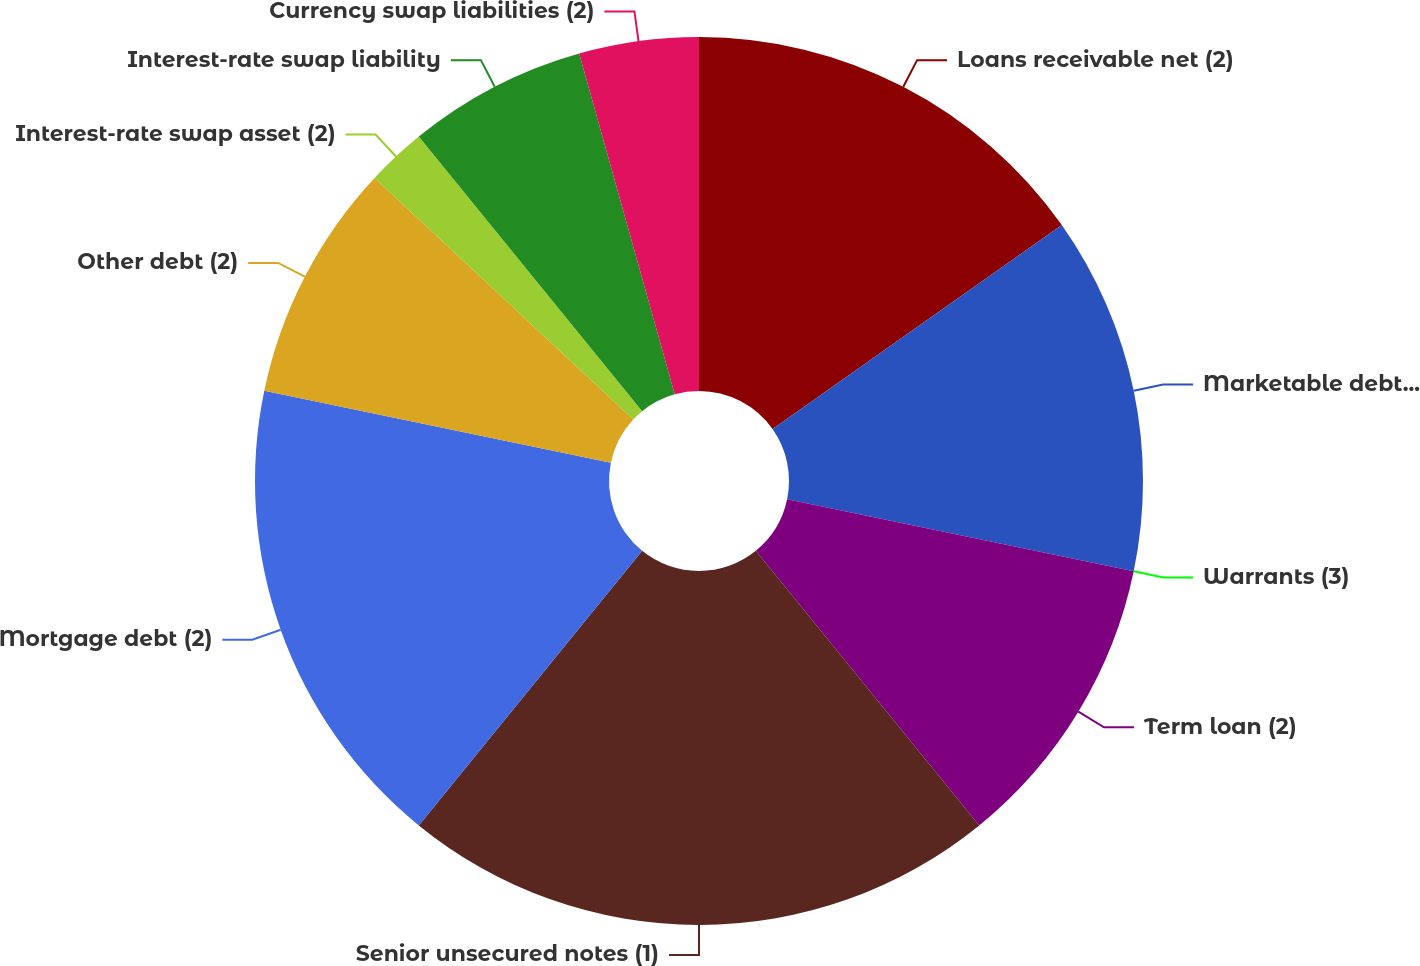<chart> <loc_0><loc_0><loc_500><loc_500><pie_chart><fcel>Loans receivable net (2)<fcel>Marketable debt securities^(3)<fcel>Warrants (3)<fcel>Term loan (2)<fcel>Senior unsecured notes (1)<fcel>Mortgage debt (2)<fcel>Other debt (2)<fcel>Interest-rate swap asset (2)<fcel>Interest-rate swap liability<fcel>Currency swap liabilities (2)<nl><fcel>15.22%<fcel>13.04%<fcel>0.0%<fcel>10.87%<fcel>21.74%<fcel>17.39%<fcel>8.7%<fcel>2.17%<fcel>6.52%<fcel>4.35%<nl></chart> 